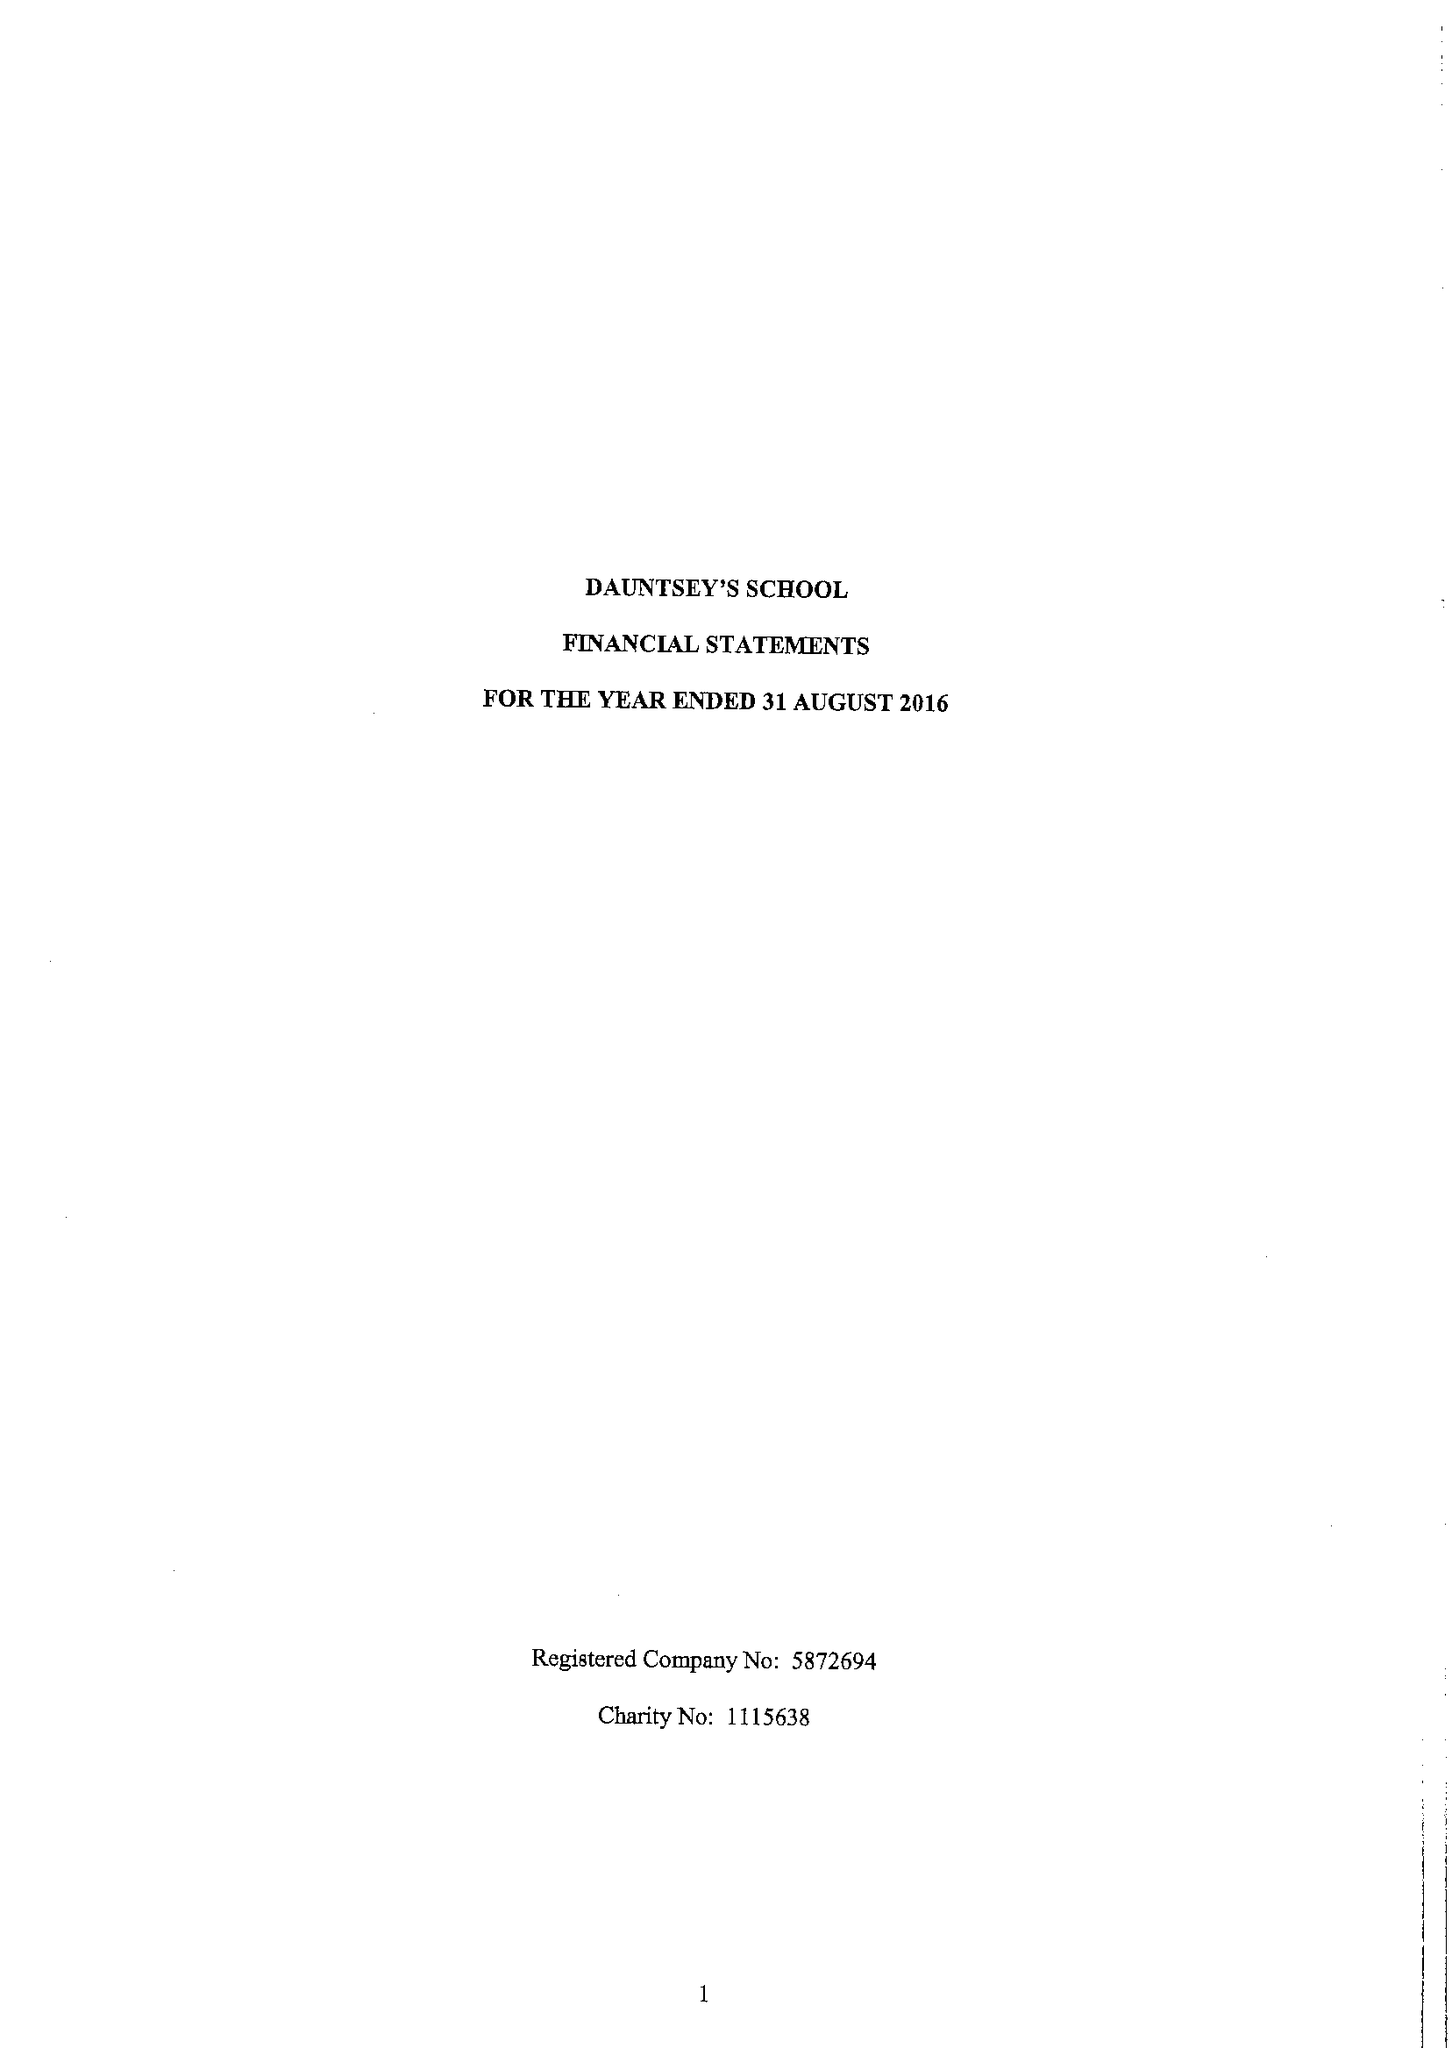What is the value for the spending_annually_in_british_pounds?
Answer the question using a single word or phrase. 17348037.00 